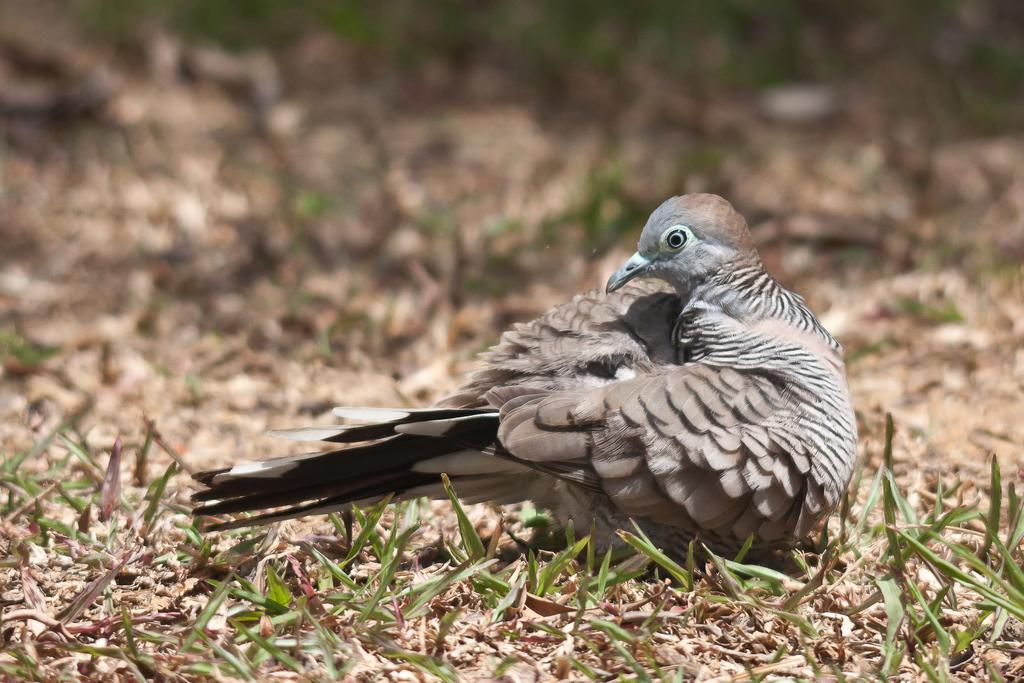Where was the image taken? The image was taken outdoors. What type of surface is visible in the image? There is a ground with grass in the image. What animal can be seen on the ground in the image? There is a bird on the ground in the image. What type of desk can be seen in the image? There is no desk present in the image; it is taken outdoors with a ground covered in grass. 